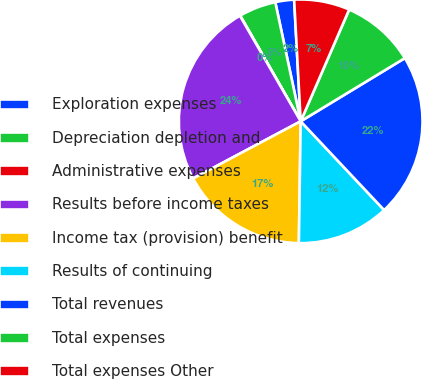<chart> <loc_0><loc_0><loc_500><loc_500><pie_chart><fcel>Exploration expenses<fcel>Depreciation depletion and<fcel>Administrative expenses<fcel>Results before income taxes<fcel>Income tax (provision) benefit<fcel>Results of continuing<fcel>Total revenues<fcel>Total expenses<fcel>Total expenses Other<nl><fcel>2.49%<fcel>4.93%<fcel>0.04%<fcel>24.46%<fcel>16.99%<fcel>12.25%<fcel>21.67%<fcel>9.81%<fcel>7.37%<nl></chart> 